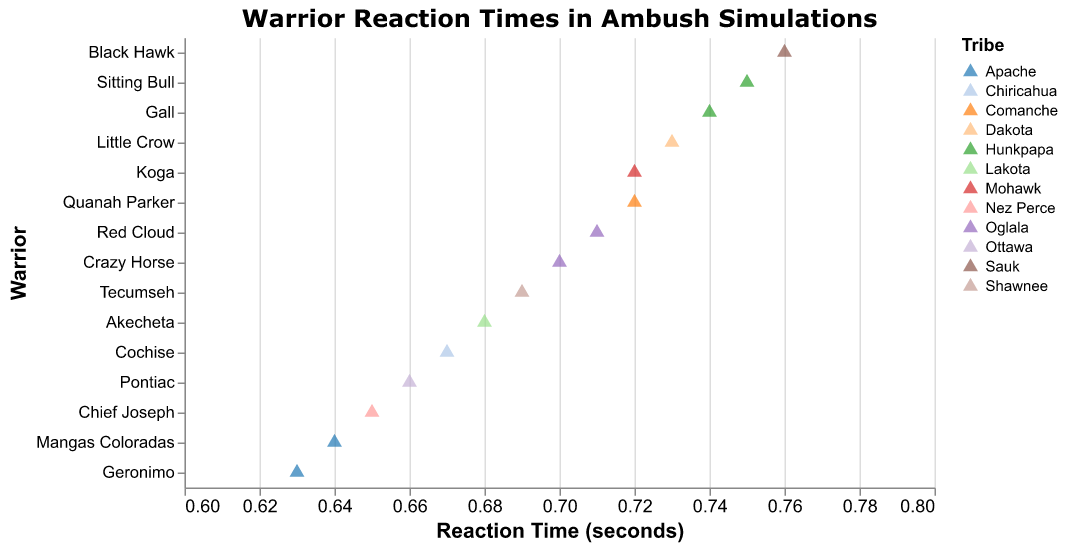What is the title of the plot? The title of the plot is usually at the top and directly visible.
Answer: Warrior Reaction Times in Ambush Simulations Which warrior has the fastest reaction time? The warrior with the lowest Reaction Time (seconds) value on the x-axis represents the fastest reaction time.
Answer: Geronimo How many warriors belong to the Oglala tribe? Look at the colors representing the tribes and count the number of points associated with Oglala.
Answer: 2 What is the range of reaction times displayed in the plot? The range can be determined by noting the minimum and maximum reaction times on the x-axis.
Answer: 0.63 to 0.76 seconds Which warrior from the Apache tribe has the slower reaction time? There are two entries for Apache, compare them to identify the slower time.
Answer: Mangas Coloradas What is the difference in reaction time between Crazy Horse and Pontiac? Subtract Pontiac's reaction time from Crazy Horse's time.
Answer: 0.04 seconds Who are the warriors with reaction times greater than 0.73 seconds? Identify the points on the plot to the right of the 0.73-second mark.
Answer: Little Crow, Gall, Black Hawk What is the average reaction time of the warriors? Sum all reaction times and divide by the number of warriors.
Answer: 0.6933 seconds How many tribes are represented in the plot? Count the unique color legend entries for tribes.
Answer: 11 Who is faster, Koga or Quanah Parker? Compare the reaction times of Koga and Quanah Parker.
Answer: They are equal 